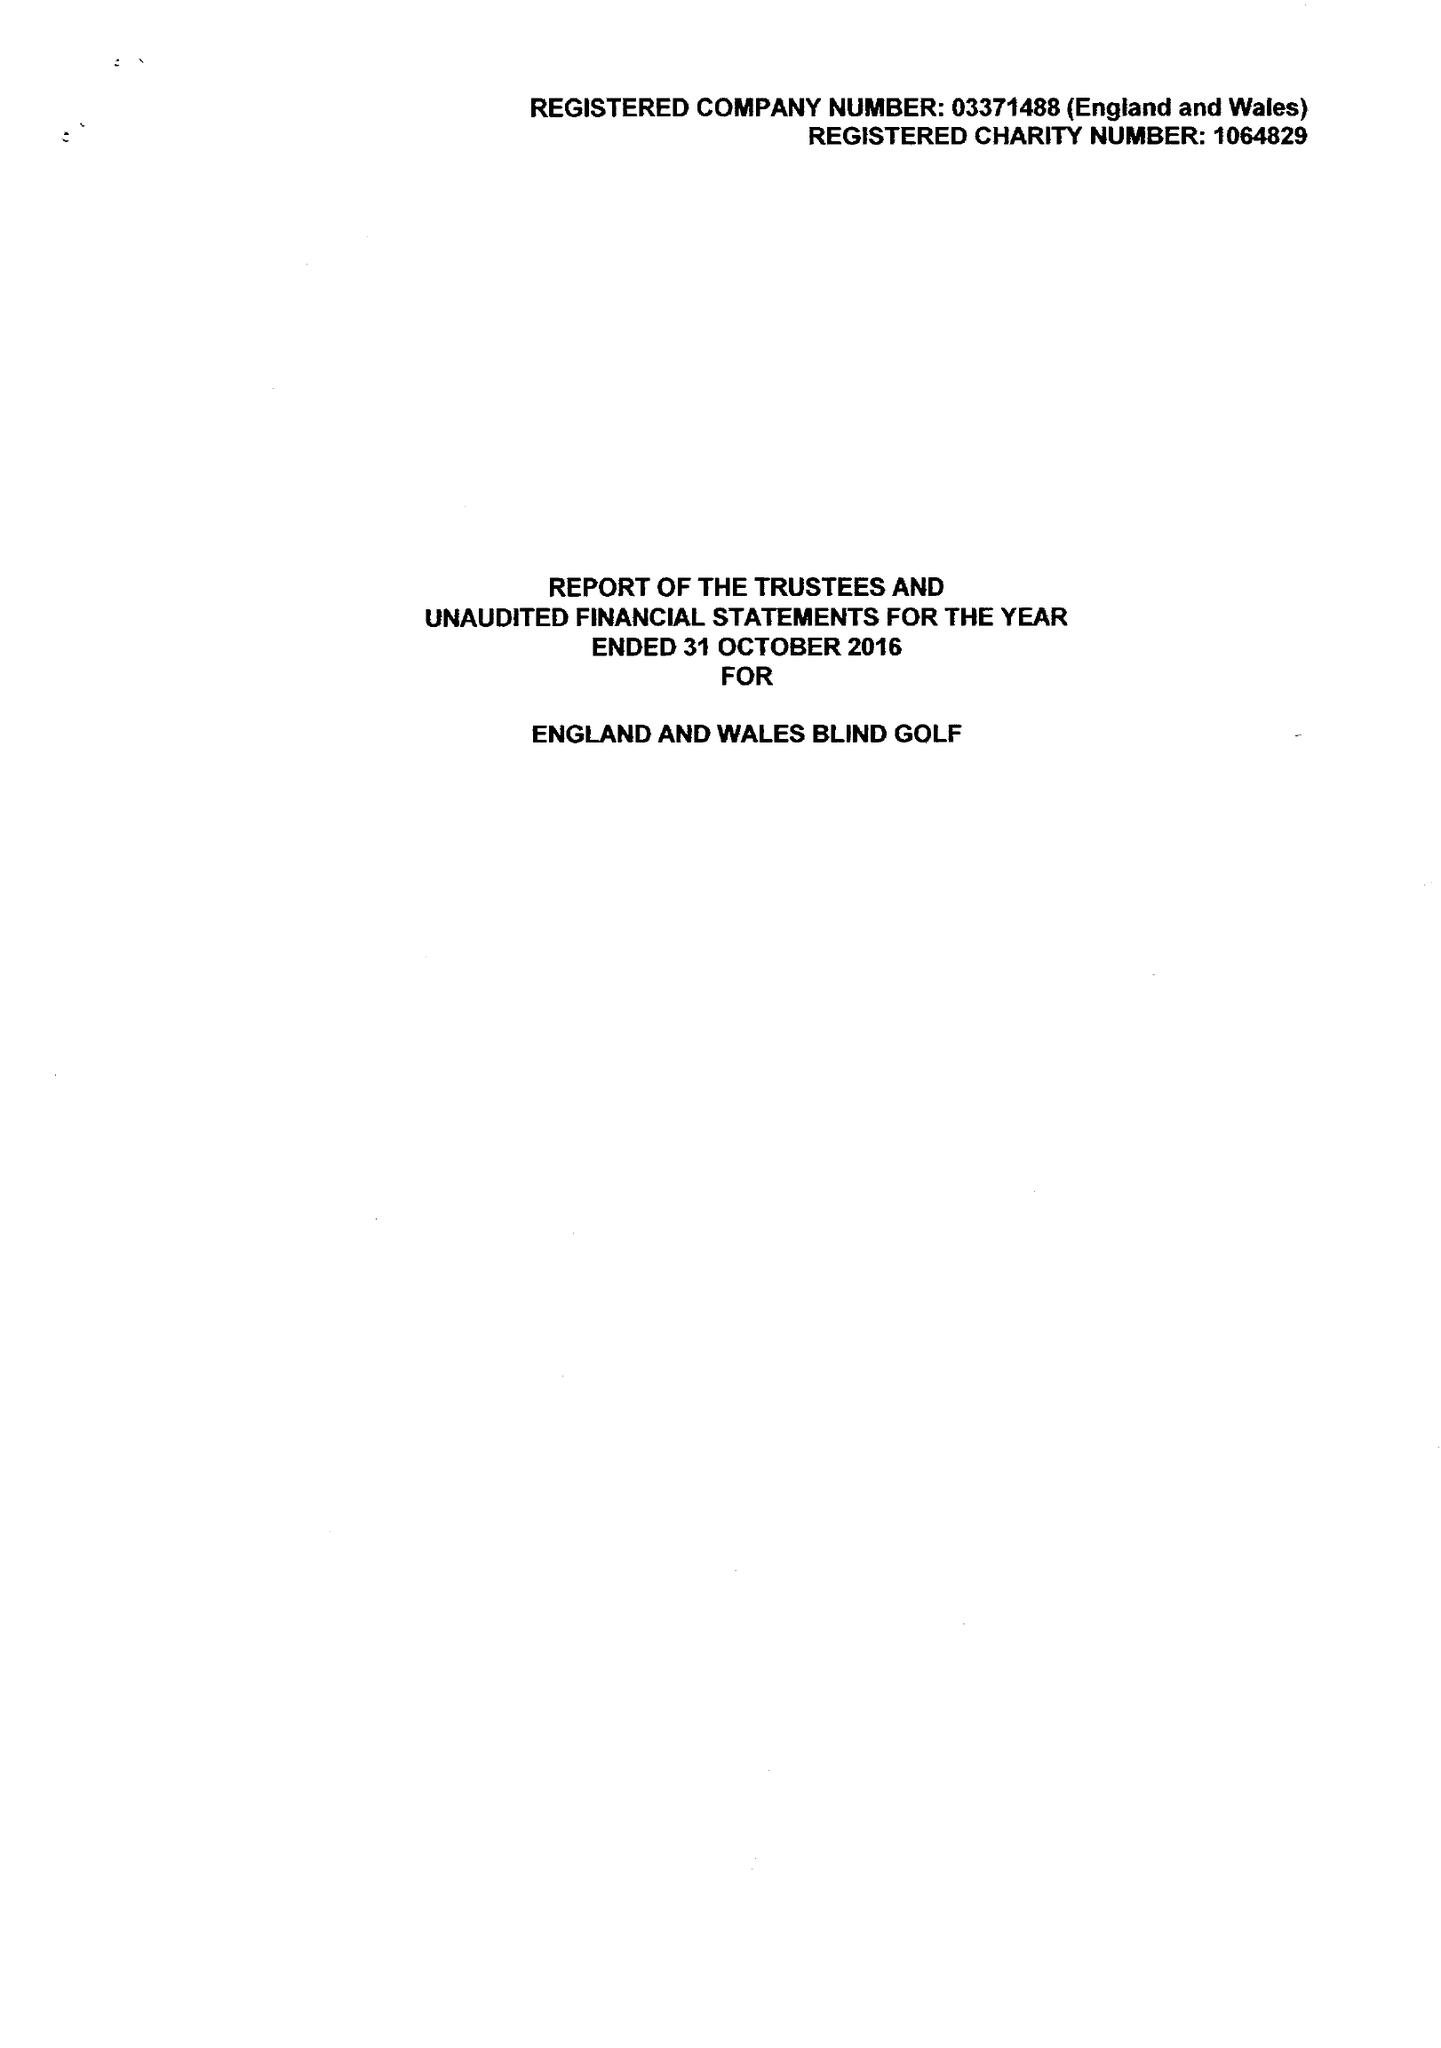What is the value for the report_date?
Answer the question using a single word or phrase. 2016-10-31 